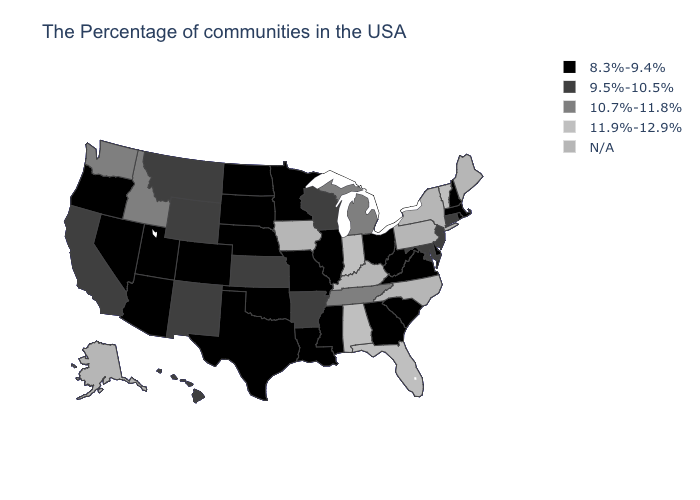Which states hav the highest value in the South?
Be succinct. Florida, Alabama. Which states hav the highest value in the West?
Concise answer only. Idaho, Washington. Does Nevada have the highest value in the USA?
Write a very short answer. No. What is the value of North Dakota?
Keep it brief. 8.3%-9.4%. Name the states that have a value in the range 11.9%-12.9%?
Give a very brief answer. Vermont, Florida, Indiana, Alabama. Name the states that have a value in the range 9.5%-10.5%?
Be succinct. Connecticut, New Jersey, Maryland, Wisconsin, Arkansas, Kansas, Wyoming, New Mexico, Montana, California, Hawaii. What is the highest value in the USA?
Give a very brief answer. 11.9%-12.9%. Name the states that have a value in the range 11.9%-12.9%?
Keep it brief. Vermont, Florida, Indiana, Alabama. Does the first symbol in the legend represent the smallest category?
Short answer required. Yes. What is the value of Maryland?
Quick response, please. 9.5%-10.5%. What is the lowest value in the USA?
Short answer required. 8.3%-9.4%. What is the value of Nebraska?
Short answer required. 8.3%-9.4%. What is the value of Georgia?
Answer briefly. 8.3%-9.4%. Name the states that have a value in the range 10.7%-11.8%?
Keep it brief. Michigan, Tennessee, Idaho, Washington. Does Idaho have the lowest value in the USA?
Give a very brief answer. No. 